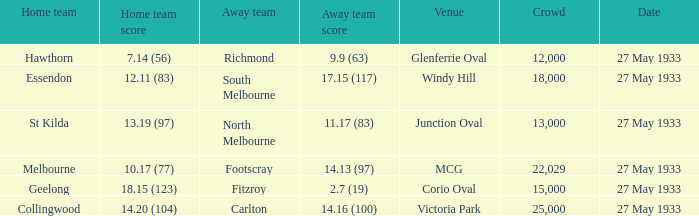Could you parse the entire table as a dict? {'header': ['Home team', 'Home team score', 'Away team', 'Away team score', 'Venue', 'Crowd', 'Date'], 'rows': [['Hawthorn', '7.14 (56)', 'Richmond', '9.9 (63)', 'Glenferrie Oval', '12,000', '27 May 1933'], ['Essendon', '12.11 (83)', 'South Melbourne', '17.15 (117)', 'Windy Hill', '18,000', '27 May 1933'], ['St Kilda', '13.19 (97)', 'North Melbourne', '11.17 (83)', 'Junction Oval', '13,000', '27 May 1933'], ['Melbourne', '10.17 (77)', 'Footscray', '14.13 (97)', 'MCG', '22,029', '27 May 1933'], ['Geelong', '18.15 (123)', 'Fitzroy', '2.7 (19)', 'Corio Oval', '15,000', '27 May 1933'], ['Collingwood', '14.20 (104)', 'Carlton', '14.16 (100)', 'Victoria Park', '25,000', '27 May 1933']]} In the event where the home team reached 1 25000.0. 